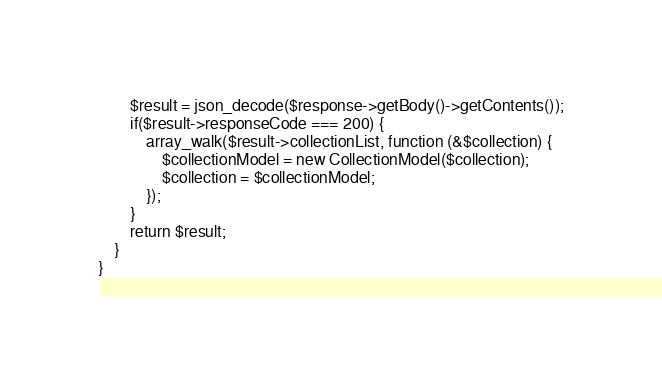<code> <loc_0><loc_0><loc_500><loc_500><_PHP_>        $result = json_decode($response->getBody()->getContents());
        if($result->responseCode === 200) {
            array_walk($result->collectionList, function (&$collection) {
                $collectionModel = new CollectionModel($collection);
                $collection = $collectionModel;
            });
        }
        return $result;
    }
}</code> 